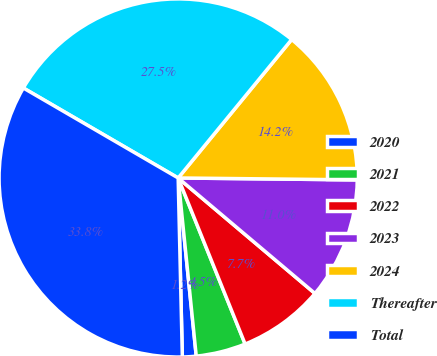Convert chart to OTSL. <chart><loc_0><loc_0><loc_500><loc_500><pie_chart><fcel>2020<fcel>2021<fcel>2022<fcel>2023<fcel>2024<fcel>Thereafter<fcel>Total<nl><fcel>1.24%<fcel>4.49%<fcel>7.74%<fcel>10.99%<fcel>14.24%<fcel>27.55%<fcel>33.75%<nl></chart> 